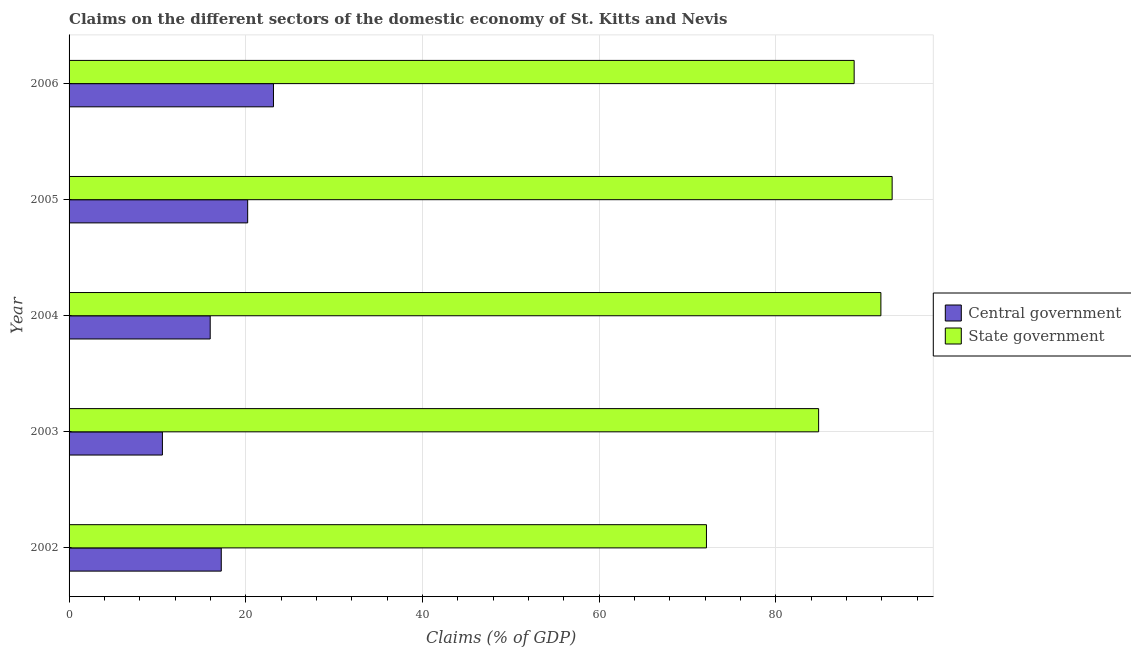How many different coloured bars are there?
Give a very brief answer. 2. Are the number of bars on each tick of the Y-axis equal?
Keep it short and to the point. Yes. How many bars are there on the 4th tick from the bottom?
Offer a terse response. 2. What is the label of the 3rd group of bars from the top?
Offer a terse response. 2004. What is the claims on central government in 2003?
Offer a terse response. 10.57. Across all years, what is the maximum claims on state government?
Provide a succinct answer. 93.17. Across all years, what is the minimum claims on state government?
Provide a short and direct response. 72.15. In which year was the claims on state government maximum?
Make the answer very short. 2005. In which year was the claims on state government minimum?
Make the answer very short. 2002. What is the total claims on central government in the graph?
Your response must be concise. 87.13. What is the difference between the claims on central government in 2003 and that in 2004?
Provide a succinct answer. -5.41. What is the difference between the claims on state government in 2003 and the claims on central government in 2006?
Provide a short and direct response. 61.71. What is the average claims on central government per year?
Keep it short and to the point. 17.43. In the year 2002, what is the difference between the claims on state government and claims on central government?
Give a very brief answer. 54.92. What is the ratio of the claims on central government in 2004 to that in 2006?
Give a very brief answer. 0.69. Is the difference between the claims on central government in 2004 and 2006 greater than the difference between the claims on state government in 2004 and 2006?
Your response must be concise. No. What is the difference between the highest and the second highest claims on central government?
Your response must be concise. 2.92. What is the difference between the highest and the lowest claims on central government?
Provide a succinct answer. 12.57. What does the 2nd bar from the top in 2003 represents?
Offer a terse response. Central government. What does the 2nd bar from the bottom in 2006 represents?
Ensure brevity in your answer.  State government. Are the values on the major ticks of X-axis written in scientific E-notation?
Provide a succinct answer. No. Does the graph contain any zero values?
Provide a short and direct response. No. How are the legend labels stacked?
Your answer should be very brief. Vertical. What is the title of the graph?
Keep it short and to the point. Claims on the different sectors of the domestic economy of St. Kitts and Nevis. Does "Quality of trade" appear as one of the legend labels in the graph?
Ensure brevity in your answer.  No. What is the label or title of the X-axis?
Offer a very short reply. Claims (% of GDP). What is the Claims (% of GDP) of Central government in 2002?
Your answer should be compact. 17.23. What is the Claims (% of GDP) of State government in 2002?
Ensure brevity in your answer.  72.15. What is the Claims (% of GDP) in Central government in 2003?
Offer a very short reply. 10.57. What is the Claims (% of GDP) in State government in 2003?
Provide a succinct answer. 84.85. What is the Claims (% of GDP) in Central government in 2004?
Your answer should be very brief. 15.98. What is the Claims (% of GDP) in State government in 2004?
Your response must be concise. 91.9. What is the Claims (% of GDP) of Central government in 2005?
Make the answer very short. 20.22. What is the Claims (% of GDP) of State government in 2005?
Offer a very short reply. 93.17. What is the Claims (% of GDP) in Central government in 2006?
Give a very brief answer. 23.14. What is the Claims (% of GDP) in State government in 2006?
Make the answer very short. 88.87. Across all years, what is the maximum Claims (% of GDP) of Central government?
Provide a succinct answer. 23.14. Across all years, what is the maximum Claims (% of GDP) of State government?
Your answer should be compact. 93.17. Across all years, what is the minimum Claims (% of GDP) of Central government?
Your answer should be very brief. 10.57. Across all years, what is the minimum Claims (% of GDP) of State government?
Make the answer very short. 72.15. What is the total Claims (% of GDP) in Central government in the graph?
Your answer should be very brief. 87.13. What is the total Claims (% of GDP) in State government in the graph?
Make the answer very short. 430.95. What is the difference between the Claims (% of GDP) in Central government in 2002 and that in 2003?
Your response must be concise. 6.66. What is the difference between the Claims (% of GDP) in State government in 2002 and that in 2003?
Provide a succinct answer. -12.7. What is the difference between the Claims (% of GDP) of Central government in 2002 and that in 2004?
Your response must be concise. 1.25. What is the difference between the Claims (% of GDP) in State government in 2002 and that in 2004?
Keep it short and to the point. -19.75. What is the difference between the Claims (% of GDP) of Central government in 2002 and that in 2005?
Ensure brevity in your answer.  -2.99. What is the difference between the Claims (% of GDP) of State government in 2002 and that in 2005?
Your answer should be very brief. -21.02. What is the difference between the Claims (% of GDP) of Central government in 2002 and that in 2006?
Offer a terse response. -5.91. What is the difference between the Claims (% of GDP) in State government in 2002 and that in 2006?
Provide a short and direct response. -16.72. What is the difference between the Claims (% of GDP) in Central government in 2003 and that in 2004?
Offer a very short reply. -5.41. What is the difference between the Claims (% of GDP) in State government in 2003 and that in 2004?
Make the answer very short. -7.05. What is the difference between the Claims (% of GDP) in Central government in 2003 and that in 2005?
Give a very brief answer. -9.65. What is the difference between the Claims (% of GDP) of State government in 2003 and that in 2005?
Offer a very short reply. -8.32. What is the difference between the Claims (% of GDP) of Central government in 2003 and that in 2006?
Offer a very short reply. -12.57. What is the difference between the Claims (% of GDP) in State government in 2003 and that in 2006?
Offer a terse response. -4.02. What is the difference between the Claims (% of GDP) of Central government in 2004 and that in 2005?
Offer a very short reply. -4.24. What is the difference between the Claims (% of GDP) in State government in 2004 and that in 2005?
Ensure brevity in your answer.  -1.27. What is the difference between the Claims (% of GDP) of Central government in 2004 and that in 2006?
Provide a succinct answer. -7.16. What is the difference between the Claims (% of GDP) in State government in 2004 and that in 2006?
Provide a succinct answer. 3.03. What is the difference between the Claims (% of GDP) of Central government in 2005 and that in 2006?
Your answer should be compact. -2.92. What is the difference between the Claims (% of GDP) of State government in 2005 and that in 2006?
Give a very brief answer. 4.3. What is the difference between the Claims (% of GDP) in Central government in 2002 and the Claims (% of GDP) in State government in 2003?
Your response must be concise. -67.62. What is the difference between the Claims (% of GDP) in Central government in 2002 and the Claims (% of GDP) in State government in 2004?
Provide a succinct answer. -74.67. What is the difference between the Claims (% of GDP) of Central government in 2002 and the Claims (% of GDP) of State government in 2005?
Keep it short and to the point. -75.94. What is the difference between the Claims (% of GDP) of Central government in 2002 and the Claims (% of GDP) of State government in 2006?
Provide a succinct answer. -71.64. What is the difference between the Claims (% of GDP) of Central government in 2003 and the Claims (% of GDP) of State government in 2004?
Keep it short and to the point. -81.33. What is the difference between the Claims (% of GDP) in Central government in 2003 and the Claims (% of GDP) in State government in 2005?
Provide a succinct answer. -82.61. What is the difference between the Claims (% of GDP) in Central government in 2003 and the Claims (% of GDP) in State government in 2006?
Keep it short and to the point. -78.31. What is the difference between the Claims (% of GDP) in Central government in 2004 and the Claims (% of GDP) in State government in 2005?
Keep it short and to the point. -77.2. What is the difference between the Claims (% of GDP) of Central government in 2004 and the Claims (% of GDP) of State government in 2006?
Your answer should be compact. -72.9. What is the difference between the Claims (% of GDP) in Central government in 2005 and the Claims (% of GDP) in State government in 2006?
Keep it short and to the point. -68.65. What is the average Claims (% of GDP) of Central government per year?
Your response must be concise. 17.43. What is the average Claims (% of GDP) of State government per year?
Keep it short and to the point. 86.19. In the year 2002, what is the difference between the Claims (% of GDP) in Central government and Claims (% of GDP) in State government?
Offer a terse response. -54.92. In the year 2003, what is the difference between the Claims (% of GDP) in Central government and Claims (% of GDP) in State government?
Make the answer very short. -74.28. In the year 2004, what is the difference between the Claims (% of GDP) of Central government and Claims (% of GDP) of State government?
Your answer should be compact. -75.92. In the year 2005, what is the difference between the Claims (% of GDP) of Central government and Claims (% of GDP) of State government?
Provide a succinct answer. -72.95. In the year 2006, what is the difference between the Claims (% of GDP) in Central government and Claims (% of GDP) in State government?
Provide a succinct answer. -65.73. What is the ratio of the Claims (% of GDP) in Central government in 2002 to that in 2003?
Provide a short and direct response. 1.63. What is the ratio of the Claims (% of GDP) in State government in 2002 to that in 2003?
Your answer should be compact. 0.85. What is the ratio of the Claims (% of GDP) in Central government in 2002 to that in 2004?
Make the answer very short. 1.08. What is the ratio of the Claims (% of GDP) in State government in 2002 to that in 2004?
Offer a very short reply. 0.79. What is the ratio of the Claims (% of GDP) of Central government in 2002 to that in 2005?
Offer a very short reply. 0.85. What is the ratio of the Claims (% of GDP) of State government in 2002 to that in 2005?
Your answer should be compact. 0.77. What is the ratio of the Claims (% of GDP) of Central government in 2002 to that in 2006?
Provide a short and direct response. 0.74. What is the ratio of the Claims (% of GDP) of State government in 2002 to that in 2006?
Your answer should be compact. 0.81. What is the ratio of the Claims (% of GDP) in Central government in 2003 to that in 2004?
Provide a short and direct response. 0.66. What is the ratio of the Claims (% of GDP) of State government in 2003 to that in 2004?
Your answer should be compact. 0.92. What is the ratio of the Claims (% of GDP) of Central government in 2003 to that in 2005?
Your answer should be very brief. 0.52. What is the ratio of the Claims (% of GDP) of State government in 2003 to that in 2005?
Your answer should be very brief. 0.91. What is the ratio of the Claims (% of GDP) in Central government in 2003 to that in 2006?
Your answer should be very brief. 0.46. What is the ratio of the Claims (% of GDP) of State government in 2003 to that in 2006?
Ensure brevity in your answer.  0.95. What is the ratio of the Claims (% of GDP) in Central government in 2004 to that in 2005?
Offer a terse response. 0.79. What is the ratio of the Claims (% of GDP) of State government in 2004 to that in 2005?
Your answer should be compact. 0.99. What is the ratio of the Claims (% of GDP) in Central government in 2004 to that in 2006?
Your response must be concise. 0.69. What is the ratio of the Claims (% of GDP) of State government in 2004 to that in 2006?
Offer a very short reply. 1.03. What is the ratio of the Claims (% of GDP) in Central government in 2005 to that in 2006?
Offer a very short reply. 0.87. What is the ratio of the Claims (% of GDP) of State government in 2005 to that in 2006?
Ensure brevity in your answer.  1.05. What is the difference between the highest and the second highest Claims (% of GDP) in Central government?
Ensure brevity in your answer.  2.92. What is the difference between the highest and the second highest Claims (% of GDP) in State government?
Keep it short and to the point. 1.27. What is the difference between the highest and the lowest Claims (% of GDP) of Central government?
Your response must be concise. 12.57. What is the difference between the highest and the lowest Claims (% of GDP) in State government?
Your response must be concise. 21.02. 